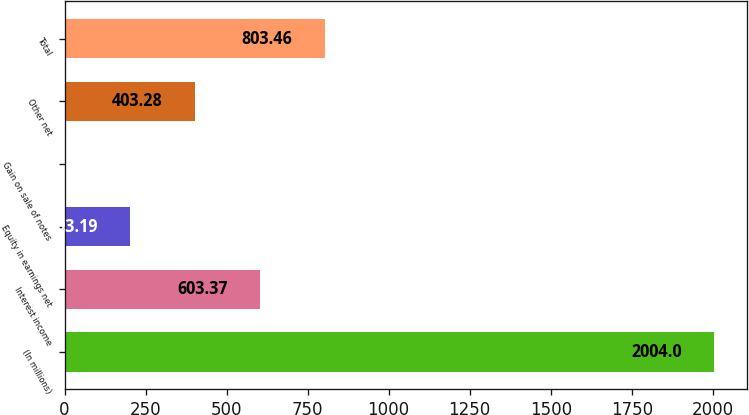Convert chart to OTSL. <chart><loc_0><loc_0><loc_500><loc_500><bar_chart><fcel>(In millions)<fcel>Interest income<fcel>Equity in earnings net<fcel>Gain on sale of notes<fcel>Other net<fcel>Total<nl><fcel>2004<fcel>603.37<fcel>203.19<fcel>3.1<fcel>403.28<fcel>803.46<nl></chart> 